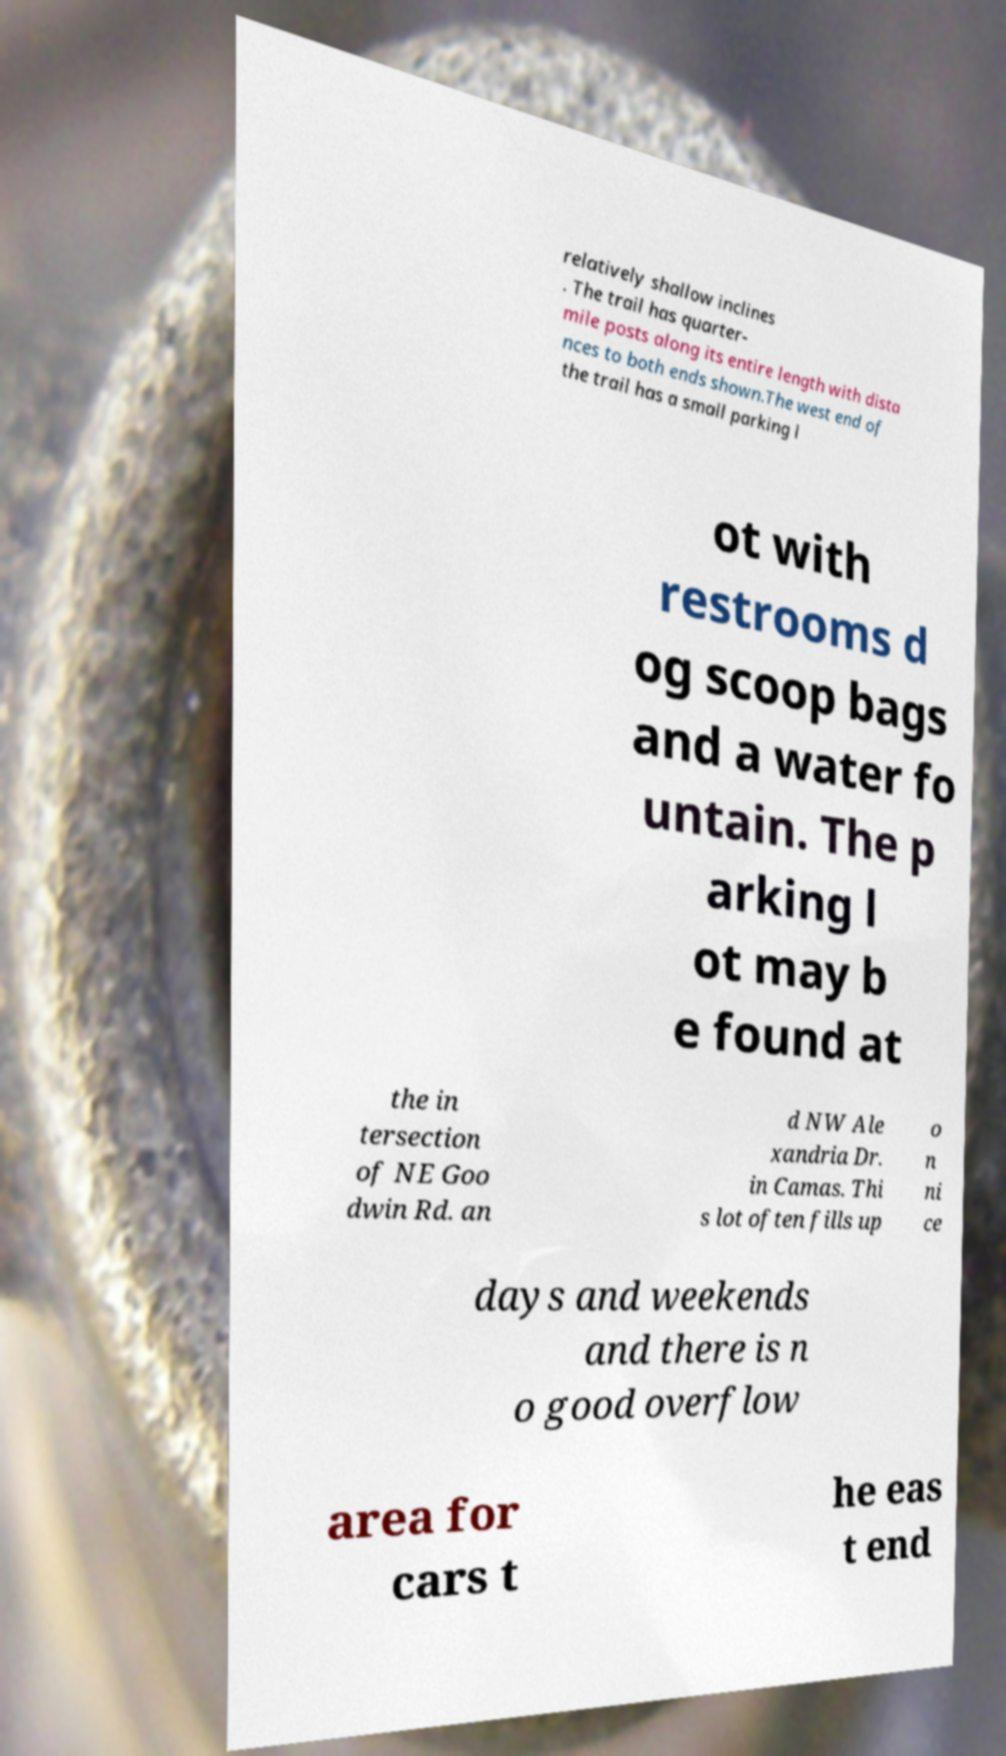Could you assist in decoding the text presented in this image and type it out clearly? relatively shallow inclines . The trail has quarter- mile posts along its entire length with dista nces to both ends shown.The west end of the trail has a small parking l ot with restrooms d og scoop bags and a water fo untain. The p arking l ot may b e found at the in tersection of NE Goo dwin Rd. an d NW Ale xandria Dr. in Camas. Thi s lot often fills up o n ni ce days and weekends and there is n o good overflow area for cars t he eas t end 